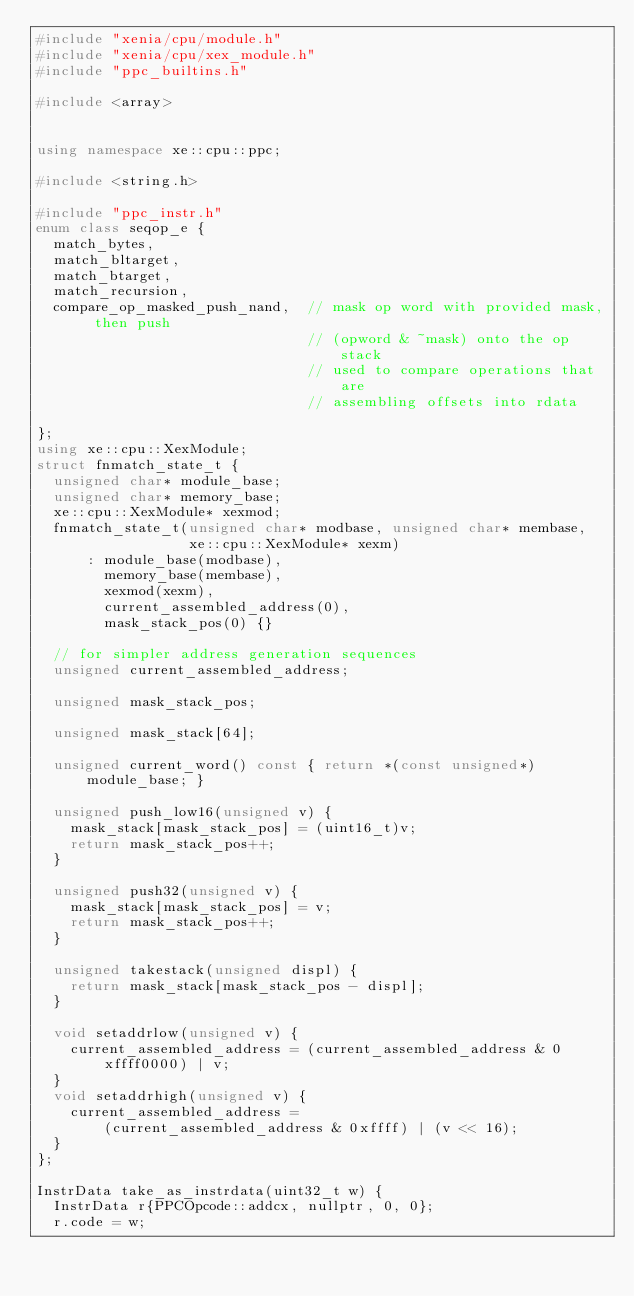<code> <loc_0><loc_0><loc_500><loc_500><_C++_>#include "xenia/cpu/module.h"
#include "xenia/cpu/xex_module.h"
#include "ppc_builtins.h"

#include <array>


using namespace xe::cpu::ppc;

#include <string.h>

#include "ppc_instr.h"
enum class seqop_e {
  match_bytes,
  match_bltarget,
  match_btarget,
  match_recursion,
  compare_op_masked_push_nand,  // mask op word with provided mask, then push
                                // (opword & ~mask) onto the op stack
                                // used to compare operations that are
                                // assembling offsets into rdata

};
using xe::cpu::XexModule;
struct fnmatch_state_t {
  unsigned char* module_base;
  unsigned char* memory_base;
  xe::cpu::XexModule* xexmod;
  fnmatch_state_t(unsigned char* modbase, unsigned char* membase,
                  xe::cpu::XexModule* xexm)
      : module_base(modbase),
        memory_base(membase),
        xexmod(xexm),
        current_assembled_address(0),
        mask_stack_pos(0) {}

  // for simpler address generation sequences
  unsigned current_assembled_address;

  unsigned mask_stack_pos;

  unsigned mask_stack[64];

  unsigned current_word() const { return *(const unsigned*)module_base; }

  unsigned push_low16(unsigned v) {
    mask_stack[mask_stack_pos] = (uint16_t)v;
    return mask_stack_pos++;
  }

  unsigned push32(unsigned v) {
    mask_stack[mask_stack_pos] = v;
    return mask_stack_pos++;
  }

  unsigned takestack(unsigned displ) {
    return mask_stack[mask_stack_pos - displ];
  }

  void setaddrlow(unsigned v) {
    current_assembled_address = (current_assembled_address & 0xffff0000) | v;
  }
  void setaddrhigh(unsigned v) {
    current_assembled_address =
        (current_assembled_address & 0xffff) | (v << 16);
  }
};

InstrData take_as_instrdata(uint32_t w) {
  InstrData r{PPCOpcode::addcx, nullptr, 0, 0};
  r.code = w;</code> 